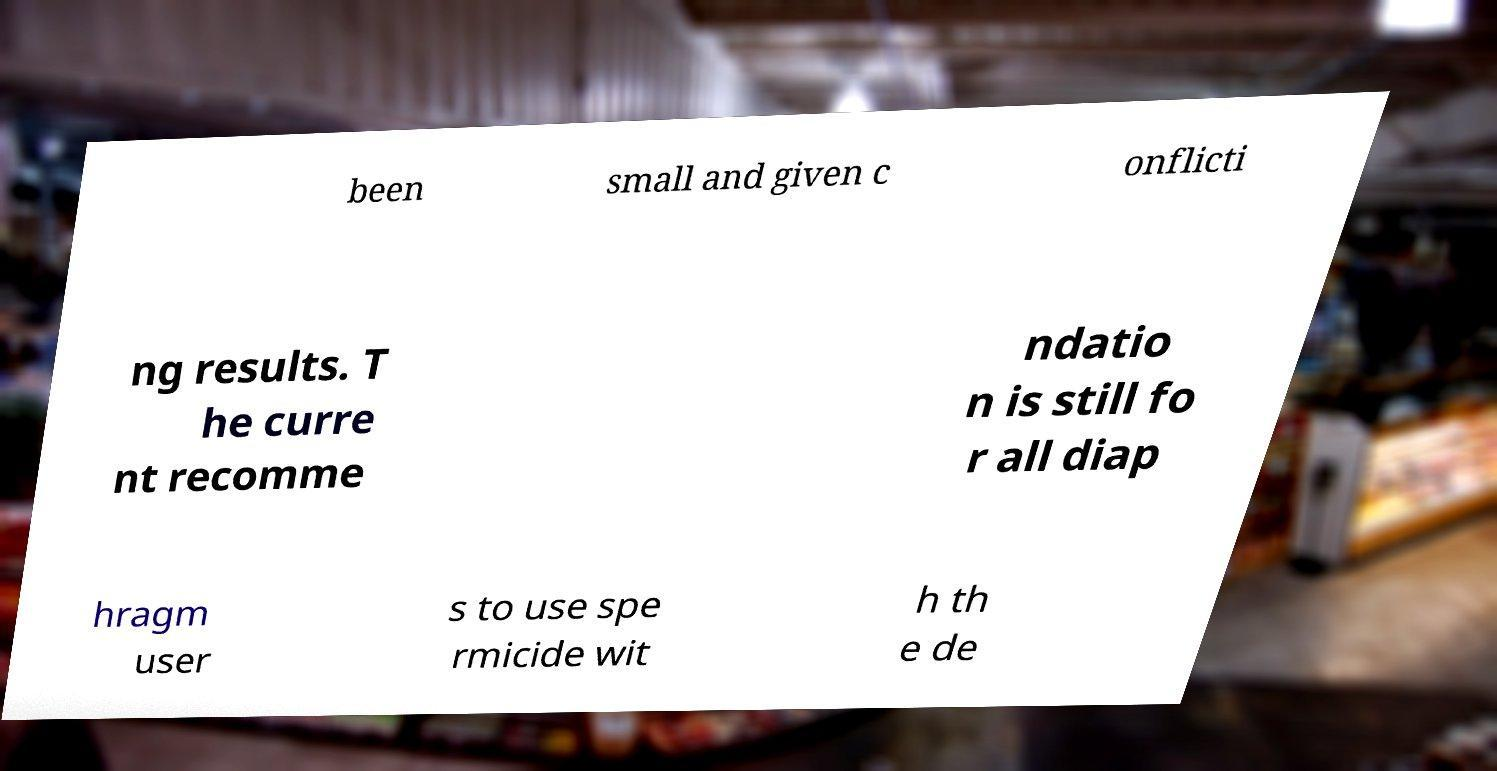I need the written content from this picture converted into text. Can you do that? been small and given c onflicti ng results. T he curre nt recomme ndatio n is still fo r all diap hragm user s to use spe rmicide wit h th e de 